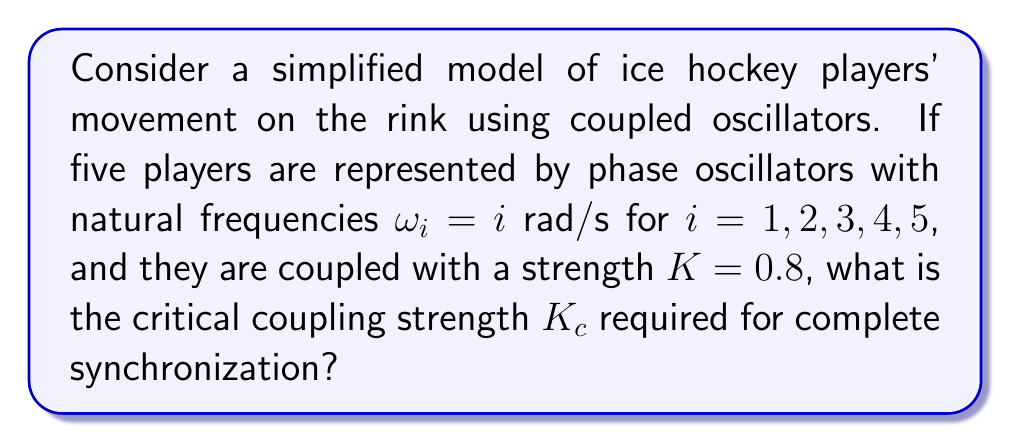Provide a solution to this math problem. To solve this problem, we'll use the Kuramoto model for coupled oscillators:

1) The Kuramoto model for N oscillators is given by:

   $$\frac{d\theta_i}{dt} = \omega_i + \frac{K}{N}\sum_{j=1}^N \sin(\theta_j - \theta_i)$$

2) For complete synchronization, we need the critical coupling strength $K_c$. This is given by:

   $$K_c = \frac{2}{\pi g(\omega_0)}$$

   where $g(\omega)$ is the distribution of natural frequencies and $\omega_0$ is the mean frequency.

3) In this case, we have a discrete set of frequencies. The mean frequency $\omega_0$ is:

   $$\omega_0 = \frac{1}{5}(1 + 2 + 3 + 4 + 5) = 3 \text{ rad/s}$$

4) For discrete frequencies, $g(\omega_0)$ is approximated by:

   $$g(\omega_0) \approx \frac{2}{N\Delta\omega}$$

   where $\Delta\omega$ is the width of the frequency distribution.

5) The width $\Delta\omega$ is the difference between the maximum and minimum frequencies:

   $$\Delta\omega = 5 - 1 = 4 \text{ rad/s}$$

6) Now we can calculate $g(\omega_0)$:

   $$g(\omega_0) \approx \frac{2}{5 \cdot 4} = 0.1 \text{ s/rad}$$

7) Finally, we can calculate $K_c$:

   $$K_c = \frac{2}{\pi g(\omega_0)} = \frac{2}{\pi \cdot 0.1} = \frac{20}{\pi} \approx 6.37 \text{ rad/s}$$
Answer: $K_c = \frac{20}{\pi} \approx 6.37 \text{ rad/s}$ 